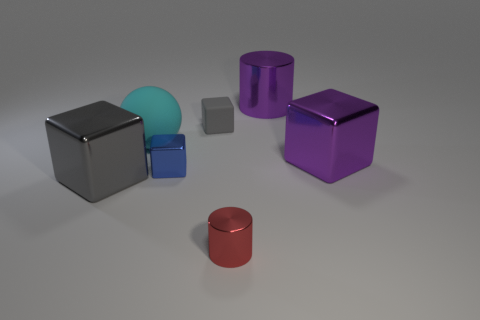Subtract all shiny cubes. How many cubes are left? 1 Subtract 1 cubes. How many cubes are left? 3 Subtract all purple cylinders. How many cylinders are left? 1 Subtract all cubes. How many objects are left? 3 Add 2 red shiny things. How many objects exist? 9 Subtract 0 brown balls. How many objects are left? 7 Subtract all red balls. Subtract all brown cylinders. How many balls are left? 1 Subtract all purple spheres. How many purple cylinders are left? 1 Subtract all blue matte objects. Subtract all large metallic objects. How many objects are left? 4 Add 4 large cyan rubber spheres. How many large cyan rubber spheres are left? 5 